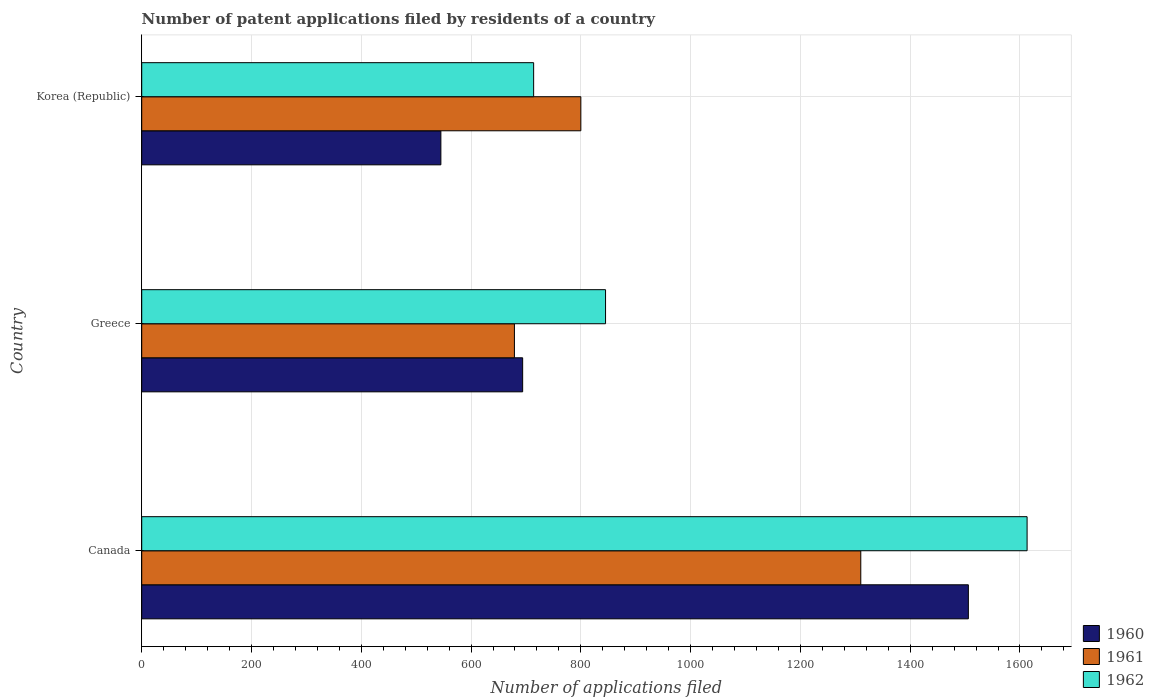How many different coloured bars are there?
Give a very brief answer. 3. Are the number of bars per tick equal to the number of legend labels?
Your response must be concise. Yes. How many bars are there on the 3rd tick from the top?
Offer a terse response. 3. How many bars are there on the 2nd tick from the bottom?
Provide a succinct answer. 3. What is the number of applications filed in 1961 in Greece?
Your answer should be very brief. 679. Across all countries, what is the maximum number of applications filed in 1961?
Your response must be concise. 1310. Across all countries, what is the minimum number of applications filed in 1961?
Your answer should be very brief. 679. What is the total number of applications filed in 1962 in the graph?
Your response must be concise. 3172. What is the difference between the number of applications filed in 1961 in Canada and that in Korea (Republic)?
Provide a short and direct response. 510. What is the difference between the number of applications filed in 1962 in Canada and the number of applications filed in 1961 in Korea (Republic)?
Your answer should be compact. 813. What is the average number of applications filed in 1962 per country?
Make the answer very short. 1057.33. What is the difference between the number of applications filed in 1961 and number of applications filed in 1962 in Korea (Republic)?
Offer a very short reply. 86. In how many countries, is the number of applications filed in 1961 greater than 480 ?
Ensure brevity in your answer.  3. What is the ratio of the number of applications filed in 1960 in Greece to that in Korea (Republic)?
Keep it short and to the point. 1.27. Is the number of applications filed in 1961 in Canada less than that in Korea (Republic)?
Provide a short and direct response. No. What is the difference between the highest and the second highest number of applications filed in 1962?
Provide a succinct answer. 768. What is the difference between the highest and the lowest number of applications filed in 1961?
Offer a very short reply. 631. In how many countries, is the number of applications filed in 1960 greater than the average number of applications filed in 1960 taken over all countries?
Give a very brief answer. 1. Is the sum of the number of applications filed in 1961 in Canada and Greece greater than the maximum number of applications filed in 1960 across all countries?
Provide a short and direct response. Yes. What does the 2nd bar from the bottom in Canada represents?
Keep it short and to the point. 1961. Is it the case that in every country, the sum of the number of applications filed in 1962 and number of applications filed in 1960 is greater than the number of applications filed in 1961?
Offer a terse response. Yes. How many bars are there?
Keep it short and to the point. 9. Are the values on the major ticks of X-axis written in scientific E-notation?
Offer a terse response. No. Where does the legend appear in the graph?
Ensure brevity in your answer.  Bottom right. How many legend labels are there?
Your answer should be very brief. 3. What is the title of the graph?
Provide a short and direct response. Number of patent applications filed by residents of a country. Does "1978" appear as one of the legend labels in the graph?
Make the answer very short. No. What is the label or title of the X-axis?
Offer a very short reply. Number of applications filed. What is the Number of applications filed of 1960 in Canada?
Give a very brief answer. 1506. What is the Number of applications filed in 1961 in Canada?
Your response must be concise. 1310. What is the Number of applications filed in 1962 in Canada?
Provide a short and direct response. 1613. What is the Number of applications filed of 1960 in Greece?
Give a very brief answer. 694. What is the Number of applications filed in 1961 in Greece?
Make the answer very short. 679. What is the Number of applications filed of 1962 in Greece?
Give a very brief answer. 845. What is the Number of applications filed of 1960 in Korea (Republic)?
Offer a terse response. 545. What is the Number of applications filed of 1961 in Korea (Republic)?
Keep it short and to the point. 800. What is the Number of applications filed in 1962 in Korea (Republic)?
Give a very brief answer. 714. Across all countries, what is the maximum Number of applications filed in 1960?
Your answer should be compact. 1506. Across all countries, what is the maximum Number of applications filed in 1961?
Your answer should be very brief. 1310. Across all countries, what is the maximum Number of applications filed of 1962?
Your response must be concise. 1613. Across all countries, what is the minimum Number of applications filed of 1960?
Your response must be concise. 545. Across all countries, what is the minimum Number of applications filed in 1961?
Offer a very short reply. 679. Across all countries, what is the minimum Number of applications filed in 1962?
Your answer should be compact. 714. What is the total Number of applications filed of 1960 in the graph?
Provide a succinct answer. 2745. What is the total Number of applications filed of 1961 in the graph?
Offer a very short reply. 2789. What is the total Number of applications filed in 1962 in the graph?
Your response must be concise. 3172. What is the difference between the Number of applications filed in 1960 in Canada and that in Greece?
Keep it short and to the point. 812. What is the difference between the Number of applications filed in 1961 in Canada and that in Greece?
Make the answer very short. 631. What is the difference between the Number of applications filed in 1962 in Canada and that in Greece?
Your answer should be very brief. 768. What is the difference between the Number of applications filed in 1960 in Canada and that in Korea (Republic)?
Your answer should be very brief. 961. What is the difference between the Number of applications filed of 1961 in Canada and that in Korea (Republic)?
Your answer should be compact. 510. What is the difference between the Number of applications filed of 1962 in Canada and that in Korea (Republic)?
Provide a short and direct response. 899. What is the difference between the Number of applications filed of 1960 in Greece and that in Korea (Republic)?
Ensure brevity in your answer.  149. What is the difference between the Number of applications filed in 1961 in Greece and that in Korea (Republic)?
Your answer should be very brief. -121. What is the difference between the Number of applications filed of 1962 in Greece and that in Korea (Republic)?
Provide a short and direct response. 131. What is the difference between the Number of applications filed of 1960 in Canada and the Number of applications filed of 1961 in Greece?
Offer a terse response. 827. What is the difference between the Number of applications filed of 1960 in Canada and the Number of applications filed of 1962 in Greece?
Your response must be concise. 661. What is the difference between the Number of applications filed in 1961 in Canada and the Number of applications filed in 1962 in Greece?
Ensure brevity in your answer.  465. What is the difference between the Number of applications filed in 1960 in Canada and the Number of applications filed in 1961 in Korea (Republic)?
Ensure brevity in your answer.  706. What is the difference between the Number of applications filed of 1960 in Canada and the Number of applications filed of 1962 in Korea (Republic)?
Provide a short and direct response. 792. What is the difference between the Number of applications filed of 1961 in Canada and the Number of applications filed of 1962 in Korea (Republic)?
Give a very brief answer. 596. What is the difference between the Number of applications filed of 1960 in Greece and the Number of applications filed of 1961 in Korea (Republic)?
Give a very brief answer. -106. What is the difference between the Number of applications filed in 1961 in Greece and the Number of applications filed in 1962 in Korea (Republic)?
Give a very brief answer. -35. What is the average Number of applications filed in 1960 per country?
Provide a succinct answer. 915. What is the average Number of applications filed of 1961 per country?
Provide a succinct answer. 929.67. What is the average Number of applications filed of 1962 per country?
Keep it short and to the point. 1057.33. What is the difference between the Number of applications filed in 1960 and Number of applications filed in 1961 in Canada?
Keep it short and to the point. 196. What is the difference between the Number of applications filed of 1960 and Number of applications filed of 1962 in Canada?
Your answer should be compact. -107. What is the difference between the Number of applications filed of 1961 and Number of applications filed of 1962 in Canada?
Make the answer very short. -303. What is the difference between the Number of applications filed of 1960 and Number of applications filed of 1961 in Greece?
Keep it short and to the point. 15. What is the difference between the Number of applications filed in 1960 and Number of applications filed in 1962 in Greece?
Provide a short and direct response. -151. What is the difference between the Number of applications filed of 1961 and Number of applications filed of 1962 in Greece?
Give a very brief answer. -166. What is the difference between the Number of applications filed of 1960 and Number of applications filed of 1961 in Korea (Republic)?
Offer a very short reply. -255. What is the difference between the Number of applications filed of 1960 and Number of applications filed of 1962 in Korea (Republic)?
Give a very brief answer. -169. What is the ratio of the Number of applications filed in 1960 in Canada to that in Greece?
Offer a very short reply. 2.17. What is the ratio of the Number of applications filed in 1961 in Canada to that in Greece?
Offer a very short reply. 1.93. What is the ratio of the Number of applications filed in 1962 in Canada to that in Greece?
Ensure brevity in your answer.  1.91. What is the ratio of the Number of applications filed of 1960 in Canada to that in Korea (Republic)?
Offer a terse response. 2.76. What is the ratio of the Number of applications filed in 1961 in Canada to that in Korea (Republic)?
Your response must be concise. 1.64. What is the ratio of the Number of applications filed in 1962 in Canada to that in Korea (Republic)?
Provide a short and direct response. 2.26. What is the ratio of the Number of applications filed of 1960 in Greece to that in Korea (Republic)?
Ensure brevity in your answer.  1.27. What is the ratio of the Number of applications filed in 1961 in Greece to that in Korea (Republic)?
Offer a very short reply. 0.85. What is the ratio of the Number of applications filed of 1962 in Greece to that in Korea (Republic)?
Your response must be concise. 1.18. What is the difference between the highest and the second highest Number of applications filed of 1960?
Make the answer very short. 812. What is the difference between the highest and the second highest Number of applications filed of 1961?
Ensure brevity in your answer.  510. What is the difference between the highest and the second highest Number of applications filed in 1962?
Your response must be concise. 768. What is the difference between the highest and the lowest Number of applications filed in 1960?
Provide a short and direct response. 961. What is the difference between the highest and the lowest Number of applications filed of 1961?
Give a very brief answer. 631. What is the difference between the highest and the lowest Number of applications filed of 1962?
Your answer should be very brief. 899. 